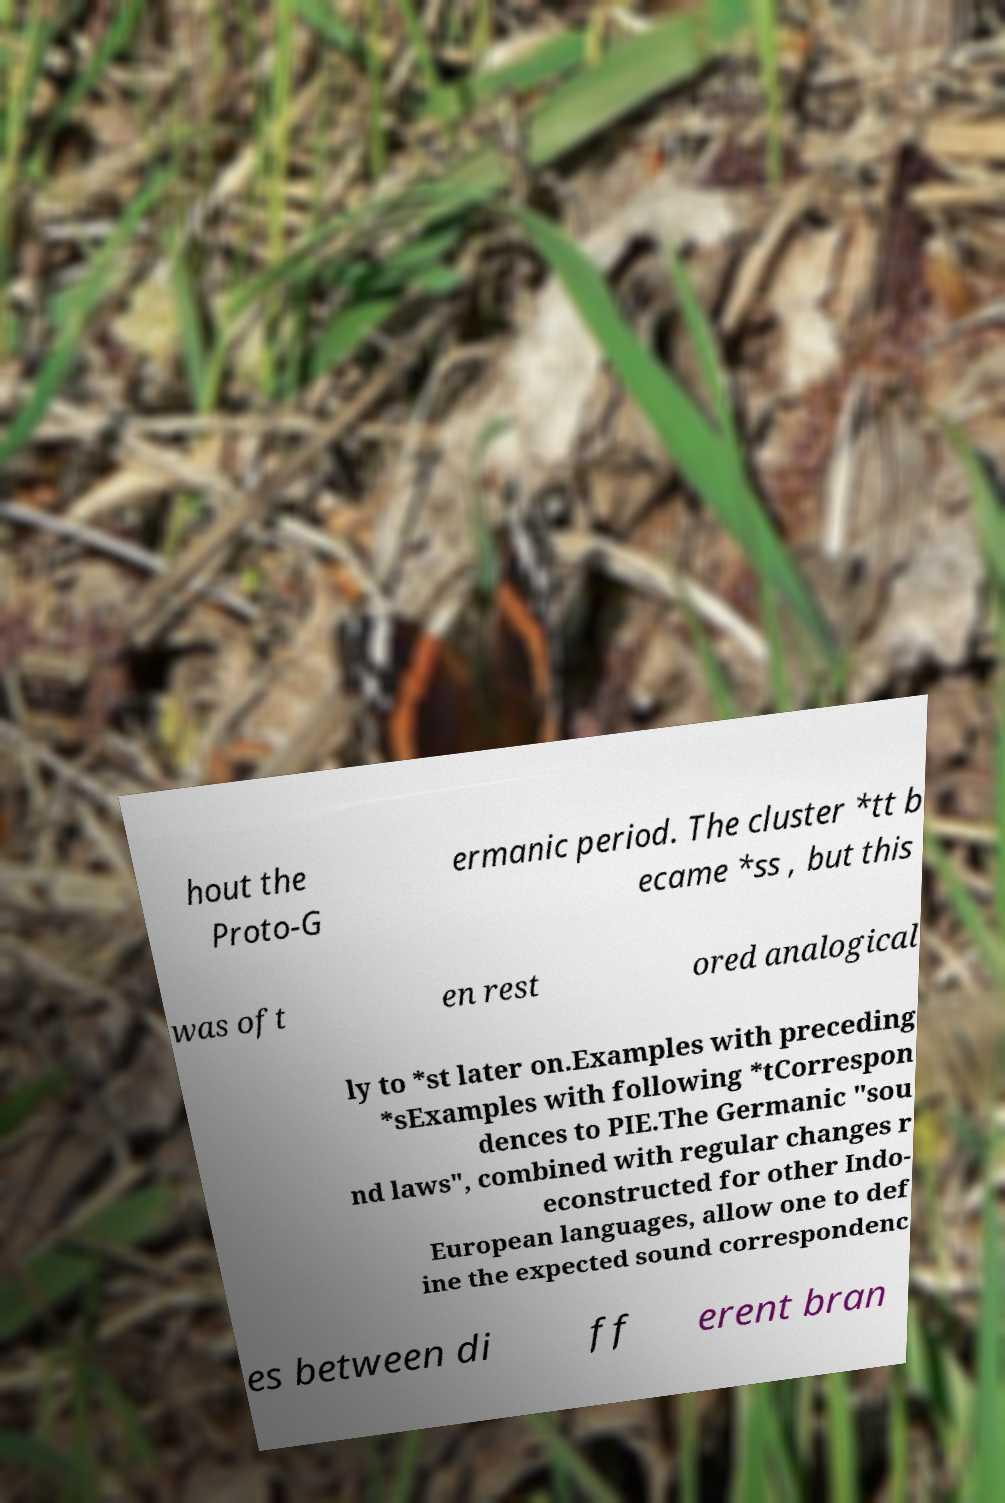There's text embedded in this image that I need extracted. Can you transcribe it verbatim? hout the Proto-G ermanic period. The cluster *tt b ecame *ss , but this was oft en rest ored analogical ly to *st later on.Examples with preceding *sExamples with following *tCorrespon dences to PIE.The Germanic "sou nd laws", combined with regular changes r econstructed for other Indo- European languages, allow one to def ine the expected sound correspondenc es between di ff erent bran 